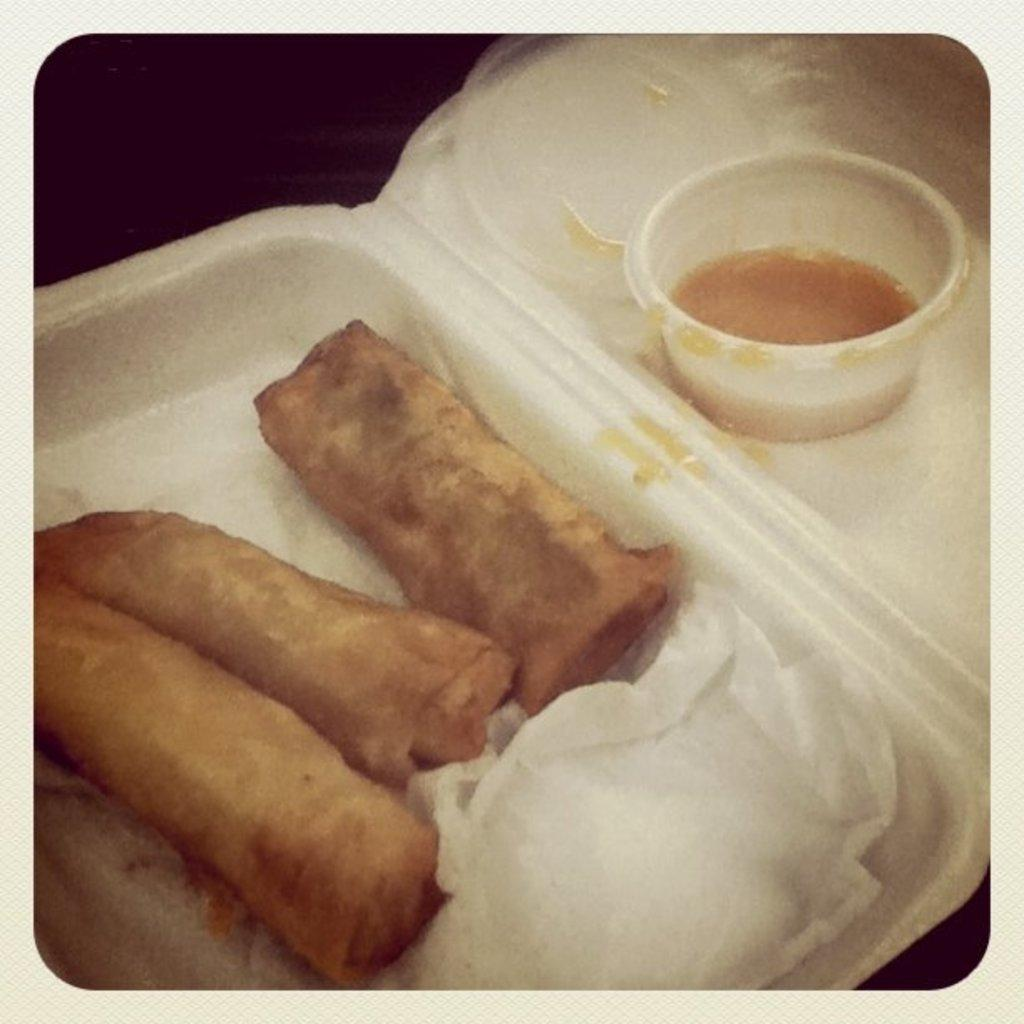What type of container is holding food in the image? There is food in a box in the image. What other item can be seen in the image besides the food? There are tissues visible in the image. What type of plane is flying over the food in the image? There is no plane visible in the image; it only shows food in a box and tissues. What type of produce is being served in the box? The facts provided do not specify the type of food in the box, so it cannot be determined if it is produce or not. 